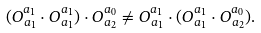<formula> <loc_0><loc_0><loc_500><loc_500>( O ^ { a _ { 1 } } _ { a _ { 1 } } \cdot O ^ { a _ { 1 } } _ { a _ { 1 } } ) \cdot O ^ { a _ { 0 } } _ { a _ { 2 } } \neq O ^ { a _ { 1 } } _ { a _ { 1 } } \cdot ( O ^ { a _ { 1 } } _ { a _ { 1 } } \cdot O ^ { a _ { 0 } } _ { a _ { 2 } } ) .</formula> 